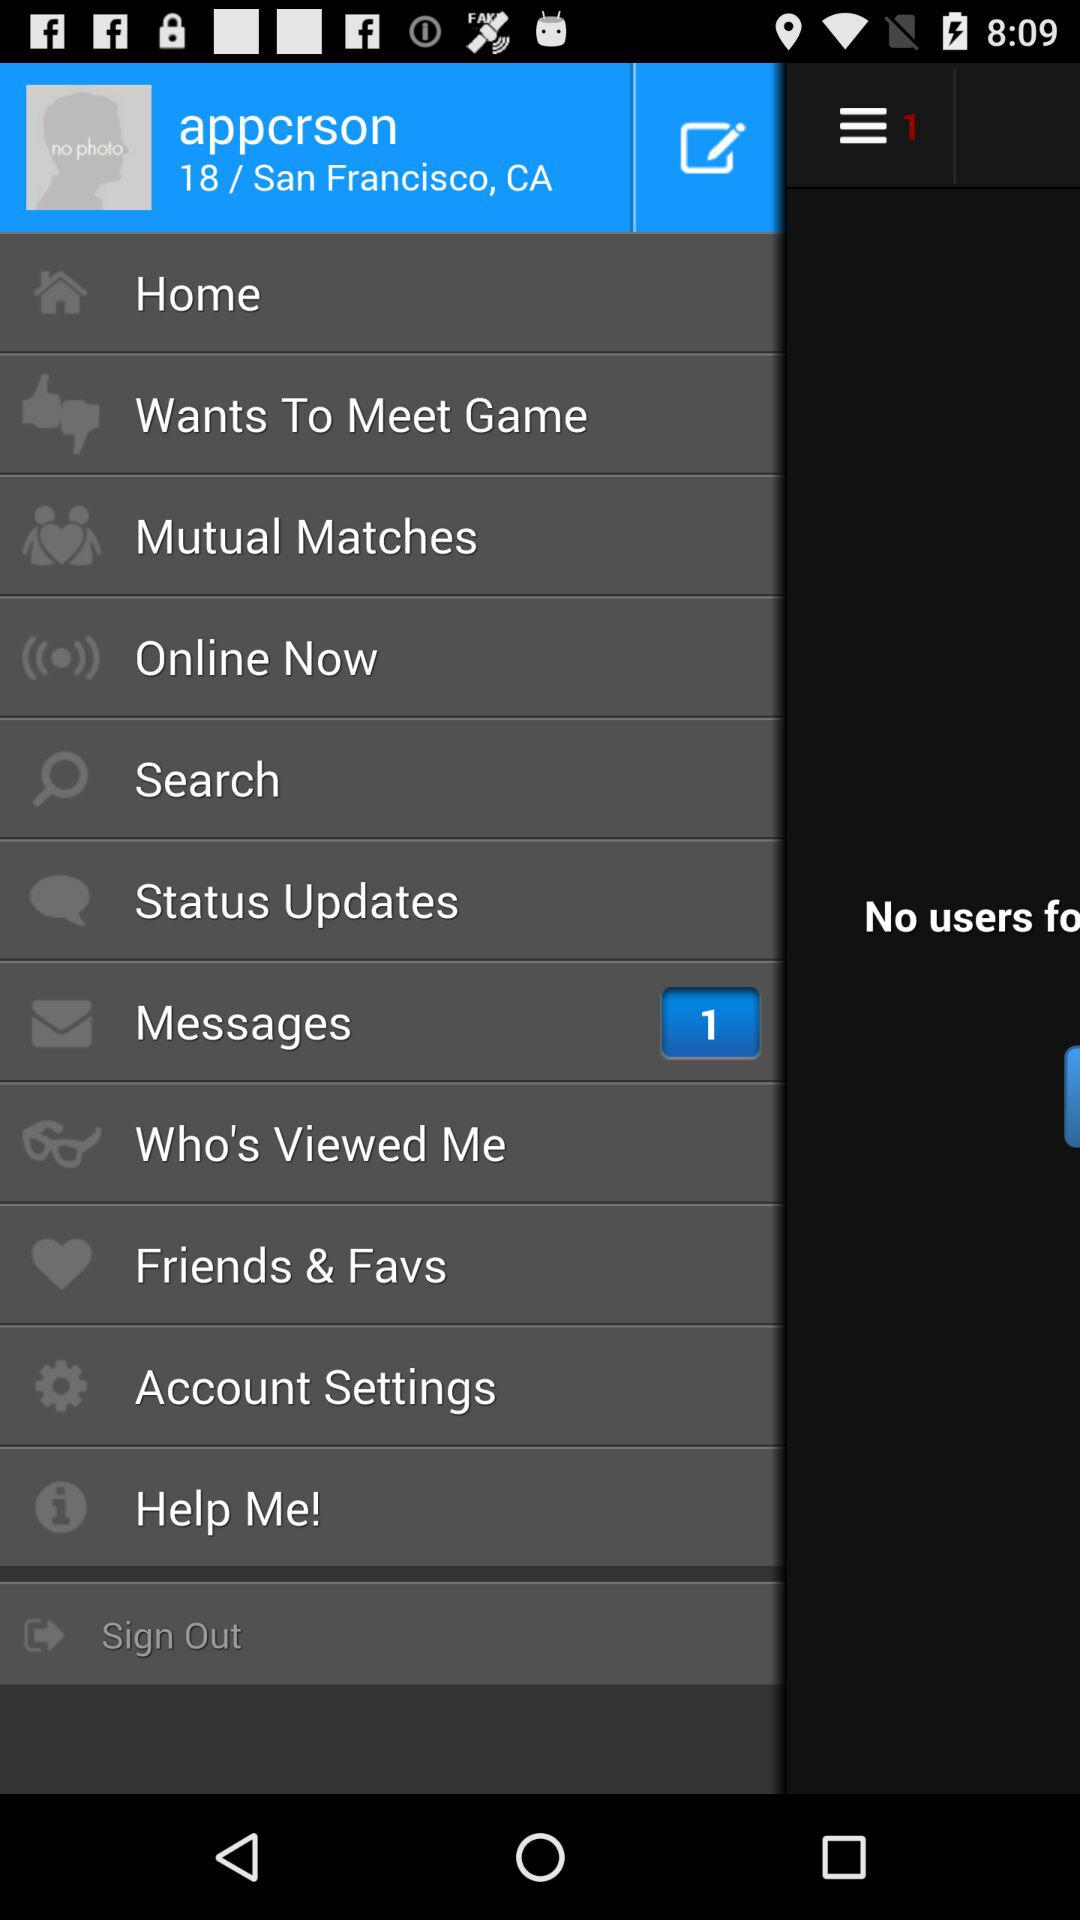What is the address? The address is San Francisco, CA. 